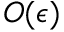Convert formula to latex. <formula><loc_0><loc_0><loc_500><loc_500>O ( \epsilon )</formula> 